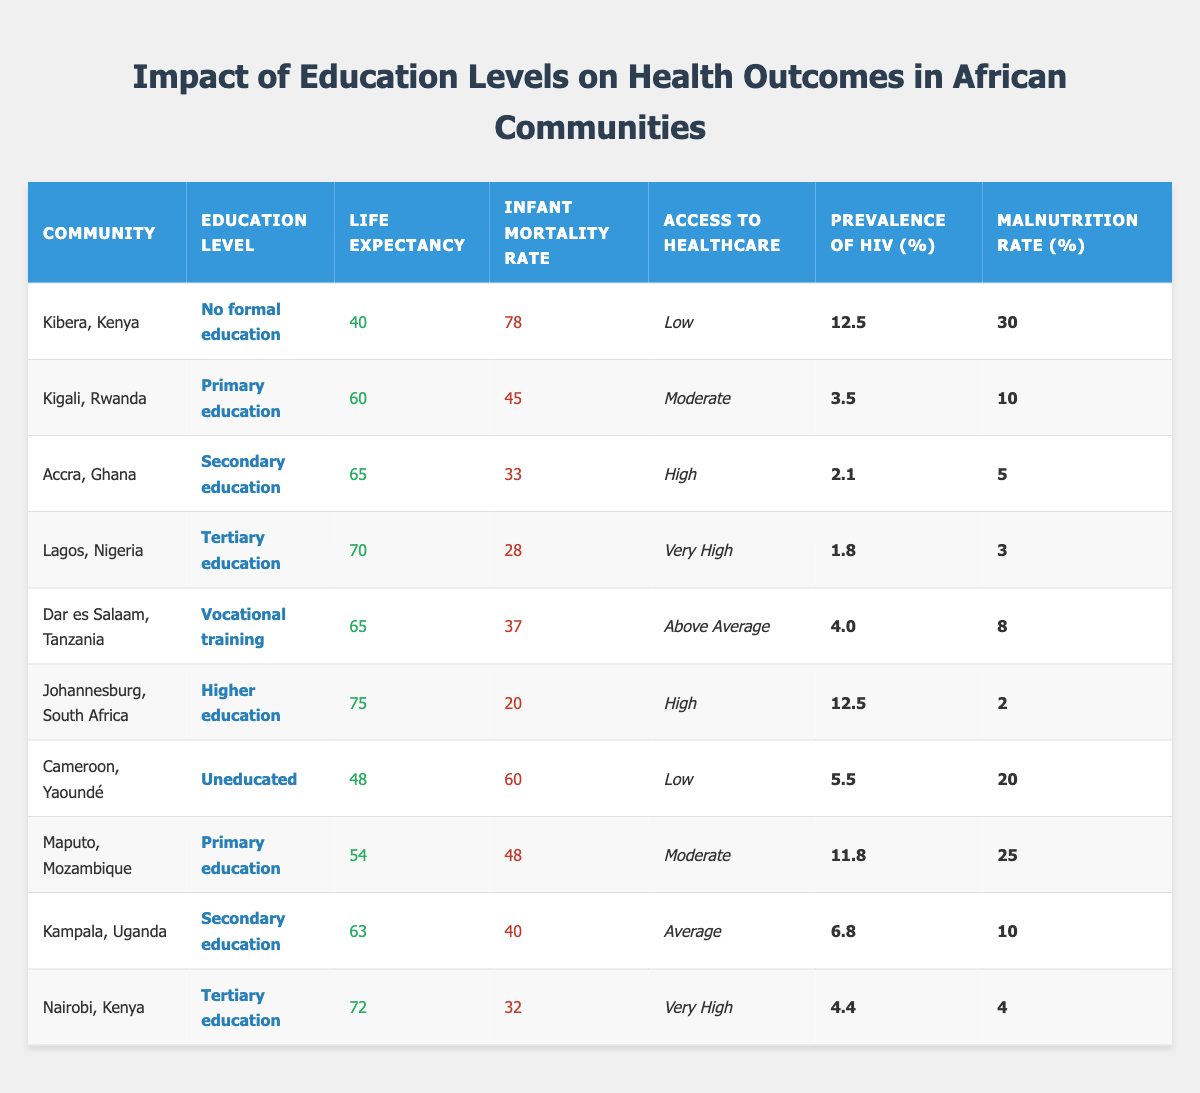What is the life expectancy in Kibera, Kenya? The table lists the life expectancy for Kibera, Kenya, which is 40 years.
Answer: 40 What are the infant mortality rates for Nairobi, Kenya? The table shows that the infant mortality rate for Nairobi, Kenya is 32.
Answer: 32 Which community has the highest access to healthcare? By observing the table, Lagos, Nigeria has "Very High" access to healthcare compared to the other communities.
Answer: Lagos, Nigeria What is the prevalence of HIV in Accra, Ghana? The table states that the prevalence of HIV in Accra, Ghana is 2.1%.
Answer: 2.1% Compare the life expectancy of communities with primary education; which one has a higher rate? Kigali, Rwanda has a life expectancy of 60 years and Maputo, Mozambique has 54 years. Kigali has a higher life expectancy than Maputo.
Answer: Kigali, Rwanda Which education level is associated with the lowest malnutrition rate? According to the data, Lagos, Nigeria with tertiary education has the lowest malnutrition rate of 3%.
Answer: 3% Is the infant mortality rate in Johannesburg, South Africa higher than in Dar es Salaam, Tanzania? Johannesburg has an infant mortality rate of 20 and Dar es Salaam has 37, so Johannesburg has a lower rate. Therefore, the statement is false.
Answer: No What is the average life expectancy of communities with secondary education? The communities with secondary education are Accra (65) and Kampala (63). The average is (65 + 63) / 2 = 64.
Answer: 64 Which community has the highest rate of infant mortality, and what is that rate? The table shows Kibera, Kenya has the highest infant mortality rate at 78.
Answer: Kibera, Kenya; 78 Are communities with higher education levels correlated with lower prevalence of HIV? Yes, as observed in the table, communities like Lagos (1.8%) and Johannesburg (12.5%) have lower HIV prevalence compared to those with no formal education like Kibera (12.5%).
Answer: Yes What is the difference in malnutrition rates between communities with no formal education and those with tertiary education? Kibera has a malnutrition rate of 30%, while Lagos has 3%. The difference is 30 - 3 = 27%.
Answer: 27% 